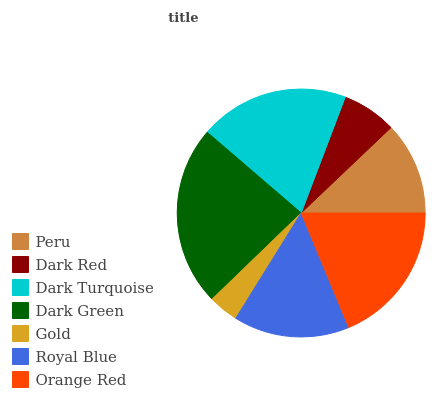Is Gold the minimum?
Answer yes or no. Yes. Is Dark Green the maximum?
Answer yes or no. Yes. Is Dark Red the minimum?
Answer yes or no. No. Is Dark Red the maximum?
Answer yes or no. No. Is Peru greater than Dark Red?
Answer yes or no. Yes. Is Dark Red less than Peru?
Answer yes or no. Yes. Is Dark Red greater than Peru?
Answer yes or no. No. Is Peru less than Dark Red?
Answer yes or no. No. Is Royal Blue the high median?
Answer yes or no. Yes. Is Royal Blue the low median?
Answer yes or no. Yes. Is Peru the high median?
Answer yes or no. No. Is Dark Turquoise the low median?
Answer yes or no. No. 